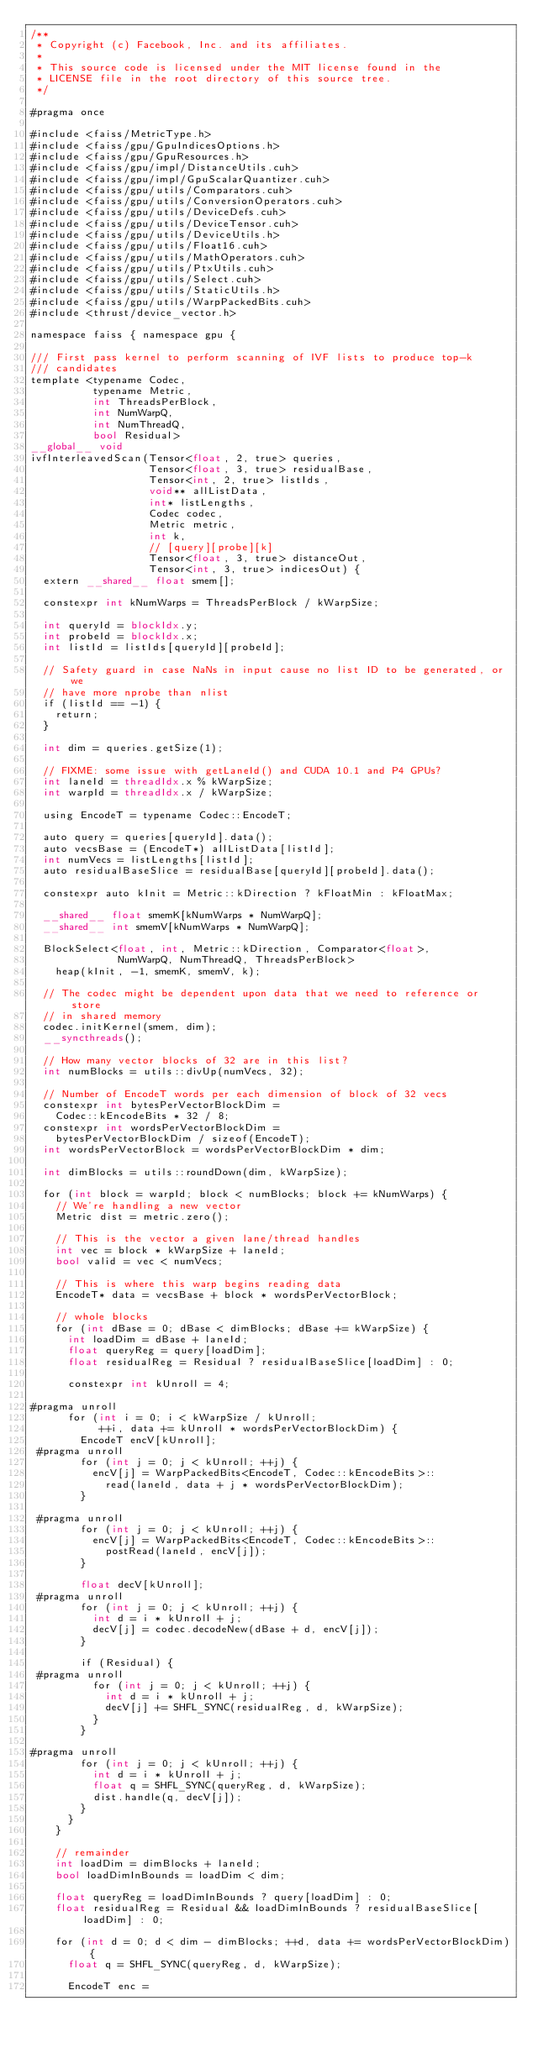<code> <loc_0><loc_0><loc_500><loc_500><_Cuda_>/**
 * Copyright (c) Facebook, Inc. and its affiliates.
 *
 * This source code is licensed under the MIT license found in the
 * LICENSE file in the root directory of this source tree.
 */

#pragma once

#include <faiss/MetricType.h>
#include <faiss/gpu/GpuIndicesOptions.h>
#include <faiss/gpu/GpuResources.h>
#include <faiss/gpu/impl/DistanceUtils.cuh>
#include <faiss/gpu/impl/GpuScalarQuantizer.cuh>
#include <faiss/gpu/utils/Comparators.cuh>
#include <faiss/gpu/utils/ConversionOperators.cuh>
#include <faiss/gpu/utils/DeviceDefs.cuh>
#include <faiss/gpu/utils/DeviceTensor.cuh>
#include <faiss/gpu/utils/DeviceUtils.h>
#include <faiss/gpu/utils/Float16.cuh>
#include <faiss/gpu/utils/MathOperators.cuh>
#include <faiss/gpu/utils/PtxUtils.cuh>
#include <faiss/gpu/utils/Select.cuh>
#include <faiss/gpu/utils/StaticUtils.h>
#include <faiss/gpu/utils/WarpPackedBits.cuh>
#include <thrust/device_vector.h>

namespace faiss { namespace gpu {

/// First pass kernel to perform scanning of IVF lists to produce top-k
/// candidates
template <typename Codec,
          typename Metric,
          int ThreadsPerBlock,
          int NumWarpQ,
          int NumThreadQ,
          bool Residual>
__global__ void
ivfInterleavedScan(Tensor<float, 2, true> queries,
                   Tensor<float, 3, true> residualBase,
                   Tensor<int, 2, true> listIds,
                   void** allListData,
                   int* listLengths,
                   Codec codec,
                   Metric metric,
                   int k,
                   // [query][probe][k]
                   Tensor<float, 3, true> distanceOut,
                   Tensor<int, 3, true> indicesOut) {
  extern __shared__ float smem[];

  constexpr int kNumWarps = ThreadsPerBlock / kWarpSize;

  int queryId = blockIdx.y;
  int probeId = blockIdx.x;
  int listId = listIds[queryId][probeId];

  // Safety guard in case NaNs in input cause no list ID to be generated, or we
  // have more nprobe than nlist
  if (listId == -1) {
    return;
  }

  int dim = queries.getSize(1);

  // FIXME: some issue with getLaneId() and CUDA 10.1 and P4 GPUs?
  int laneId = threadIdx.x % kWarpSize;
  int warpId = threadIdx.x / kWarpSize;

  using EncodeT = typename Codec::EncodeT;

  auto query = queries[queryId].data();
  auto vecsBase = (EncodeT*) allListData[listId];
  int numVecs = listLengths[listId];
  auto residualBaseSlice = residualBase[queryId][probeId].data();

  constexpr auto kInit = Metric::kDirection ? kFloatMin : kFloatMax;

  __shared__ float smemK[kNumWarps * NumWarpQ];
  __shared__ int smemV[kNumWarps * NumWarpQ];

  BlockSelect<float, int, Metric::kDirection, Comparator<float>,
              NumWarpQ, NumThreadQ, ThreadsPerBlock>
    heap(kInit, -1, smemK, smemV, k);

  // The codec might be dependent upon data that we need to reference or store
  // in shared memory
  codec.initKernel(smem, dim);
  __syncthreads();

  // How many vector blocks of 32 are in this list?
  int numBlocks = utils::divUp(numVecs, 32);

  // Number of EncodeT words per each dimension of block of 32 vecs
  constexpr int bytesPerVectorBlockDim =
    Codec::kEncodeBits * 32 / 8;
  constexpr int wordsPerVectorBlockDim =
    bytesPerVectorBlockDim / sizeof(EncodeT);
  int wordsPerVectorBlock = wordsPerVectorBlockDim * dim;

  int dimBlocks = utils::roundDown(dim, kWarpSize);

  for (int block = warpId; block < numBlocks; block += kNumWarps) {
    // We're handling a new vector
    Metric dist = metric.zero();

    // This is the vector a given lane/thread handles
    int vec = block * kWarpSize + laneId;
    bool valid = vec < numVecs;

    // This is where this warp begins reading data
    EncodeT* data = vecsBase + block * wordsPerVectorBlock;

    // whole blocks
    for (int dBase = 0; dBase < dimBlocks; dBase += kWarpSize) {
      int loadDim = dBase + laneId;
      float queryReg = query[loadDim];
      float residualReg = Residual ? residualBaseSlice[loadDim] : 0;

      constexpr int kUnroll = 4;

#pragma unroll
      for (int i = 0; i < kWarpSize / kUnroll;
           ++i, data += kUnroll * wordsPerVectorBlockDim) {
        EncodeT encV[kUnroll];
 #pragma unroll
        for (int j = 0; j < kUnroll; ++j) {
          encV[j] = WarpPackedBits<EncodeT, Codec::kEncodeBits>::
            read(laneId, data + j * wordsPerVectorBlockDim);
        }

 #pragma unroll
        for (int j = 0; j < kUnroll; ++j) {
          encV[j] = WarpPackedBits<EncodeT, Codec::kEncodeBits>::
            postRead(laneId, encV[j]);
        }

        float decV[kUnroll];
 #pragma unroll
        for (int j = 0; j < kUnroll; ++j) {
          int d = i * kUnroll + j;
          decV[j] = codec.decodeNew(dBase + d, encV[j]);
        }

        if (Residual) {
 #pragma unroll
          for (int j = 0; j < kUnroll; ++j) {
            int d = i * kUnroll + j;
            decV[j] += SHFL_SYNC(residualReg, d, kWarpSize);
          }
        }

#pragma unroll
        for (int j = 0; j < kUnroll; ++j) {
          int d = i * kUnroll + j;
          float q = SHFL_SYNC(queryReg, d, kWarpSize);
          dist.handle(q, decV[j]);
        }
      }
    }

    // remainder
    int loadDim = dimBlocks + laneId;
    bool loadDimInBounds = loadDim < dim;

    float queryReg = loadDimInBounds ? query[loadDim] : 0;
    float residualReg = Residual && loadDimInBounds ? residualBaseSlice[loadDim] : 0;

    for (int d = 0; d < dim - dimBlocks; ++d, data += wordsPerVectorBlockDim) {
      float q = SHFL_SYNC(queryReg, d, kWarpSize);

      EncodeT enc =</code> 